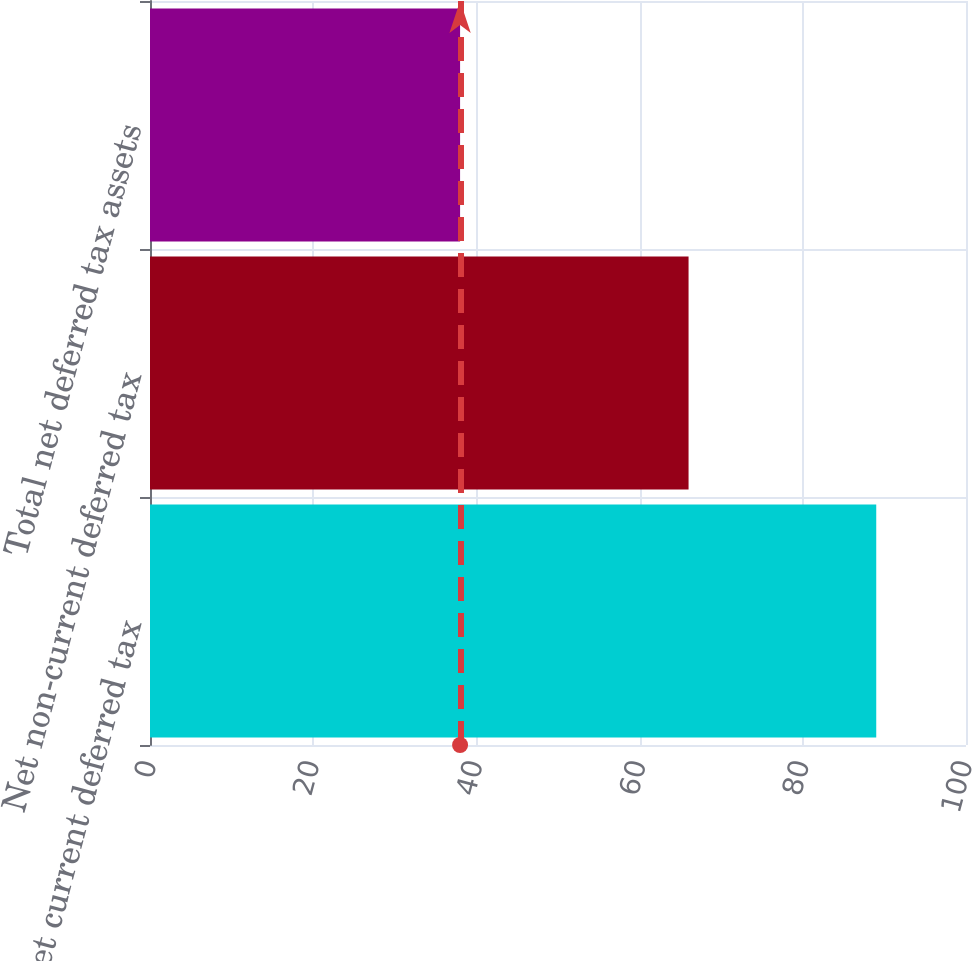Convert chart to OTSL. <chart><loc_0><loc_0><loc_500><loc_500><bar_chart><fcel>Net current deferred tax<fcel>Net non-current deferred tax<fcel>Total net deferred tax assets<nl><fcel>89<fcel>66<fcel>38<nl></chart> 